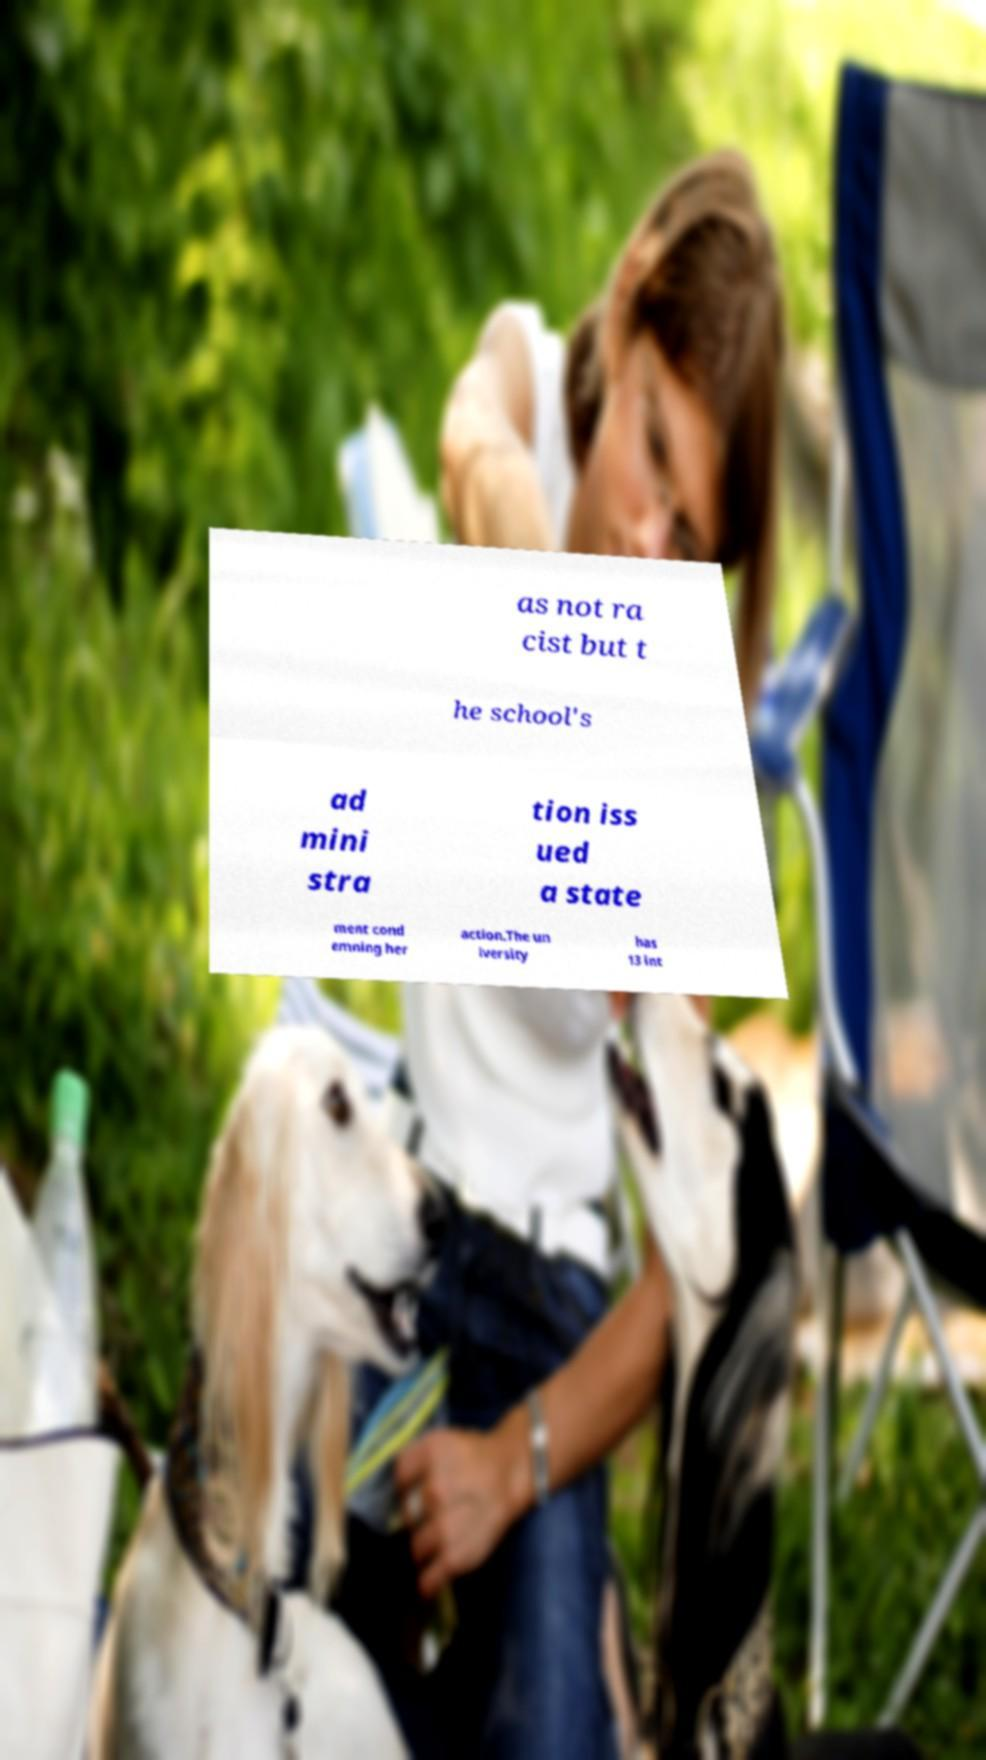There's text embedded in this image that I need extracted. Can you transcribe it verbatim? as not ra cist but t he school's ad mini stra tion iss ued a state ment cond emning her action.The un iversity has 13 int 